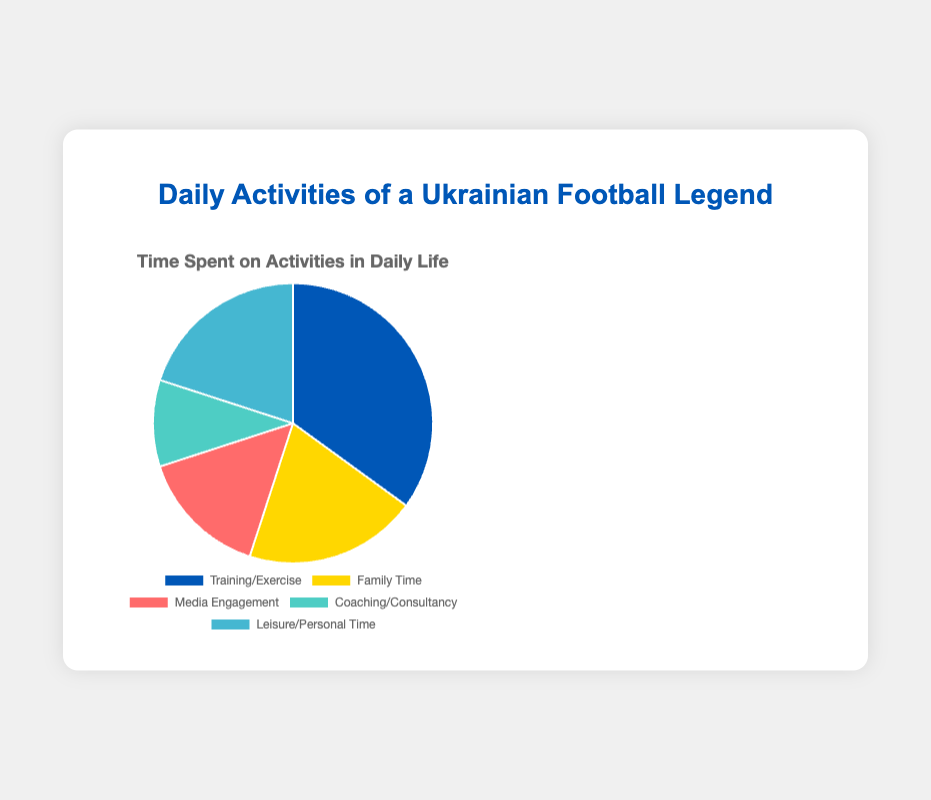What is the activity with the highest time spent? The activity with the highest time spent is represented by the largest slice in the pie chart, which is at 35%. This corresponds to Training/Exercise.
Answer: Training/Exercise Which activities have an equal amount of time spent? The pie chart shows that both Family Time and Leisure/Personal Time have slices of the same size, representing 20% of the total time each.
Answer: Family Time and Leisure/Personal Time How much more time is spent on Training/Exercise compared to Media Engagement? Training/Exercise takes up 35% of the time, while Media Engagement takes up 15%. The difference is 35% - 15% = 20%.
Answer: 20% Which activity has the least amount of time spent? The smallest slice in the pie chart represents the activity with the least time spent. This slice corresponds to Coaching/Consultancy, which accounts for 10% of the total time.
Answer: Coaching/Consultancy What is the combined percentage of time spent on Family Time and Leisure/Personal Time? Both Family Time and Leisure/Personal Time each take up 20% of the time. Together, they account for 20% + 20% = 40% of the total time.
Answer: 40% What percentage of time is spent on activities other than Training/Exercise? Training/Exercise takes up 35% of the time. To find the percentage for other activities, we subtract this from 100%: 100% - 35% = 65%.
Answer: 65% Is more time spent on Media Engagement or Coaching/Consultancy? The pie chart shows that Media Engagement takes up 15% of the time, while Coaching/Consultancy takes up 10%. Therefore, more time is spent on Media Engagement.
Answer: Media Engagement What is the percentage difference between the time spent on Family Time and Media Engagement? Family Time accounts for 20% of the time, while Media Engagement accounts for 15%. The percentage difference between them is 20% - 15% = 5%.
Answer: 5% How many activities occupy less than 20% of the total time? From the pie chart, Media Engagement (15%) and Coaching/Consultancy (10%) each occupy less than 20%. Therefore, there are 2 activities.
Answer: 2 